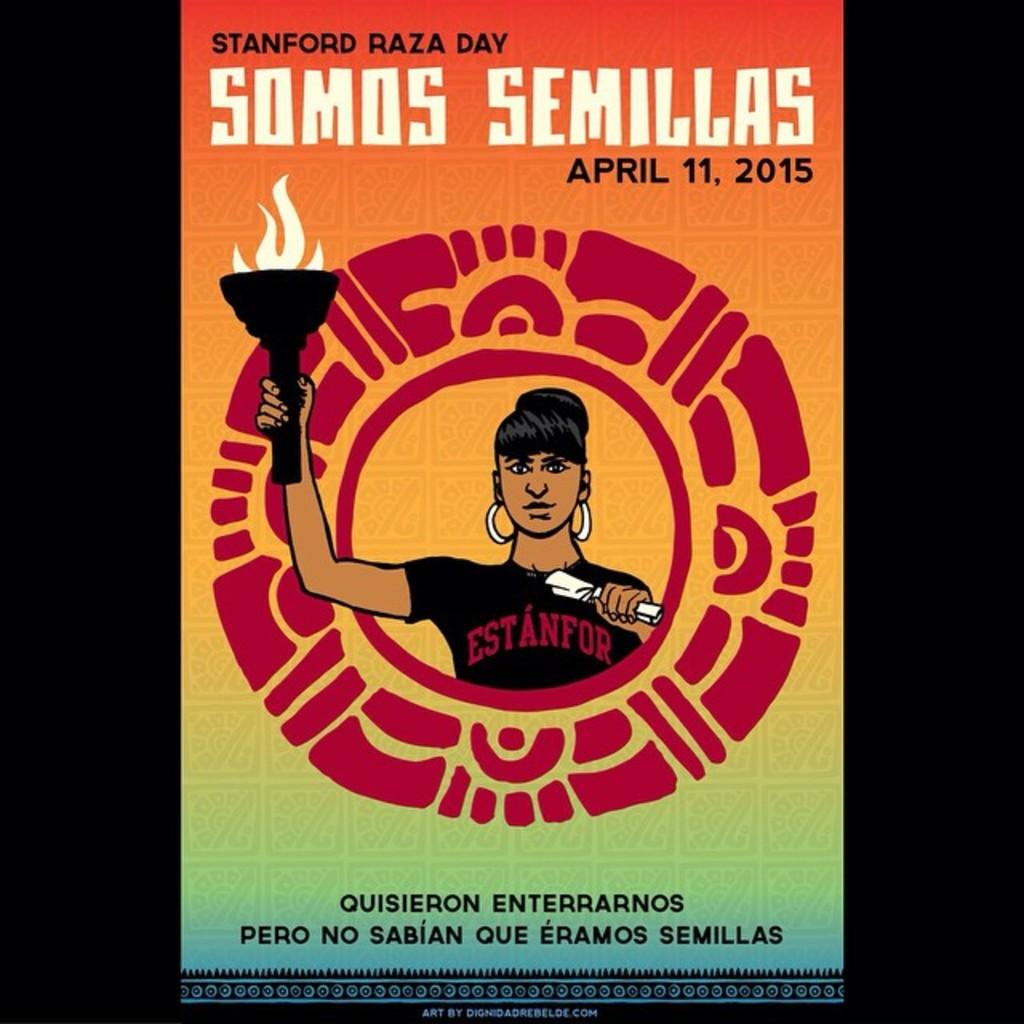<image>
Write a terse but informative summary of the picture. Standford Raza Day took place on April 11, 2015. 